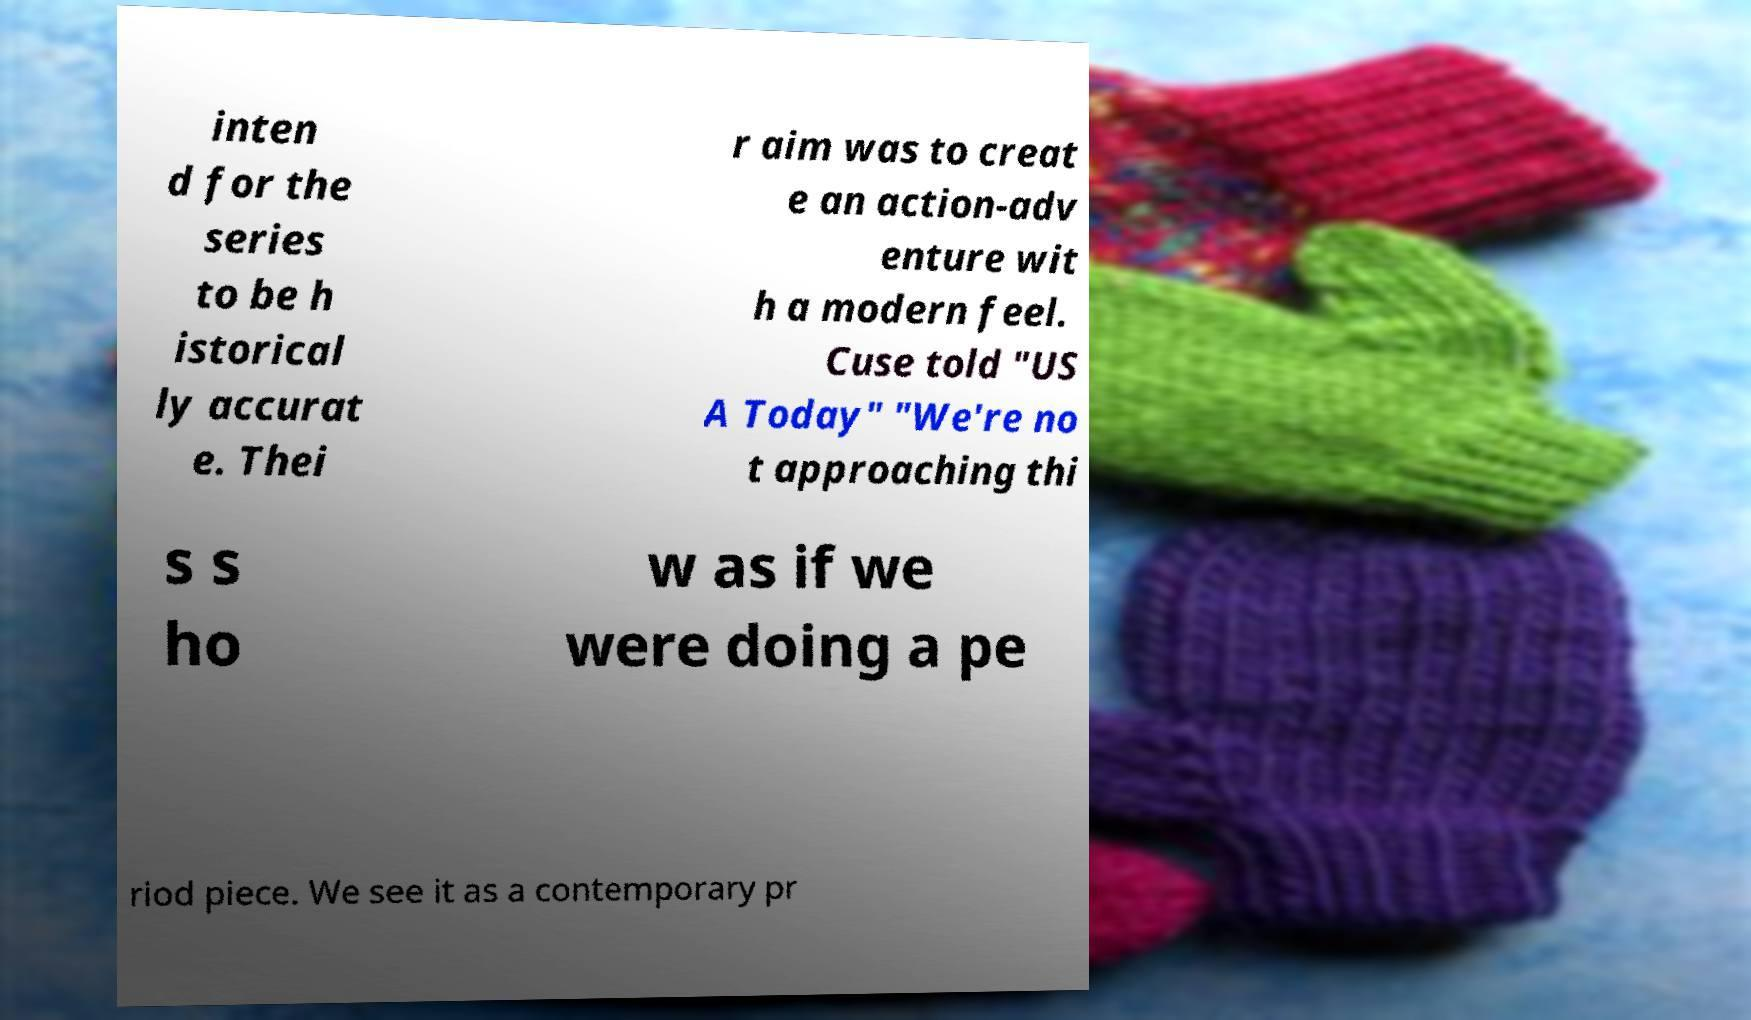For documentation purposes, I need the text within this image transcribed. Could you provide that? inten d for the series to be h istorical ly accurat e. Thei r aim was to creat e an action-adv enture wit h a modern feel. Cuse told "US A Today" "We're no t approaching thi s s ho w as if we were doing a pe riod piece. We see it as a contemporary pr 